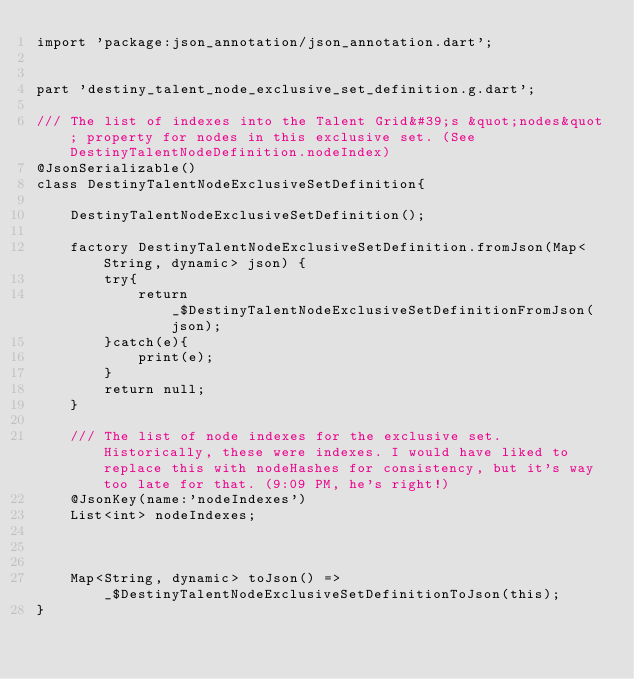Convert code to text. <code><loc_0><loc_0><loc_500><loc_500><_Dart_>import 'package:json_annotation/json_annotation.dart';


part 'destiny_talent_node_exclusive_set_definition.g.dart';

/// The list of indexes into the Talent Grid&#39;s &quot;nodes&quot; property for nodes in this exclusive set. (See DestinyTalentNodeDefinition.nodeIndex)
@JsonSerializable()
class DestinyTalentNodeExclusiveSetDefinition{
	
	DestinyTalentNodeExclusiveSetDefinition();

	factory DestinyTalentNodeExclusiveSetDefinition.fromJson(Map<String, dynamic> json) {
		try{
			return _$DestinyTalentNodeExclusiveSetDefinitionFromJson(json);
		}catch(e){
			print(e);
		}
		return null;
	}

	/// The list of node indexes for the exclusive set. Historically, these were indexes. I would have liked to replace this with nodeHashes for consistency, but it's way too late for that. (9:09 PM, he's right!)
	@JsonKey(name:'nodeIndexes')
	List<int> nodeIndexes;

	
	
	Map<String, dynamic> toJson() => _$DestinyTalentNodeExclusiveSetDefinitionToJson(this);
}</code> 